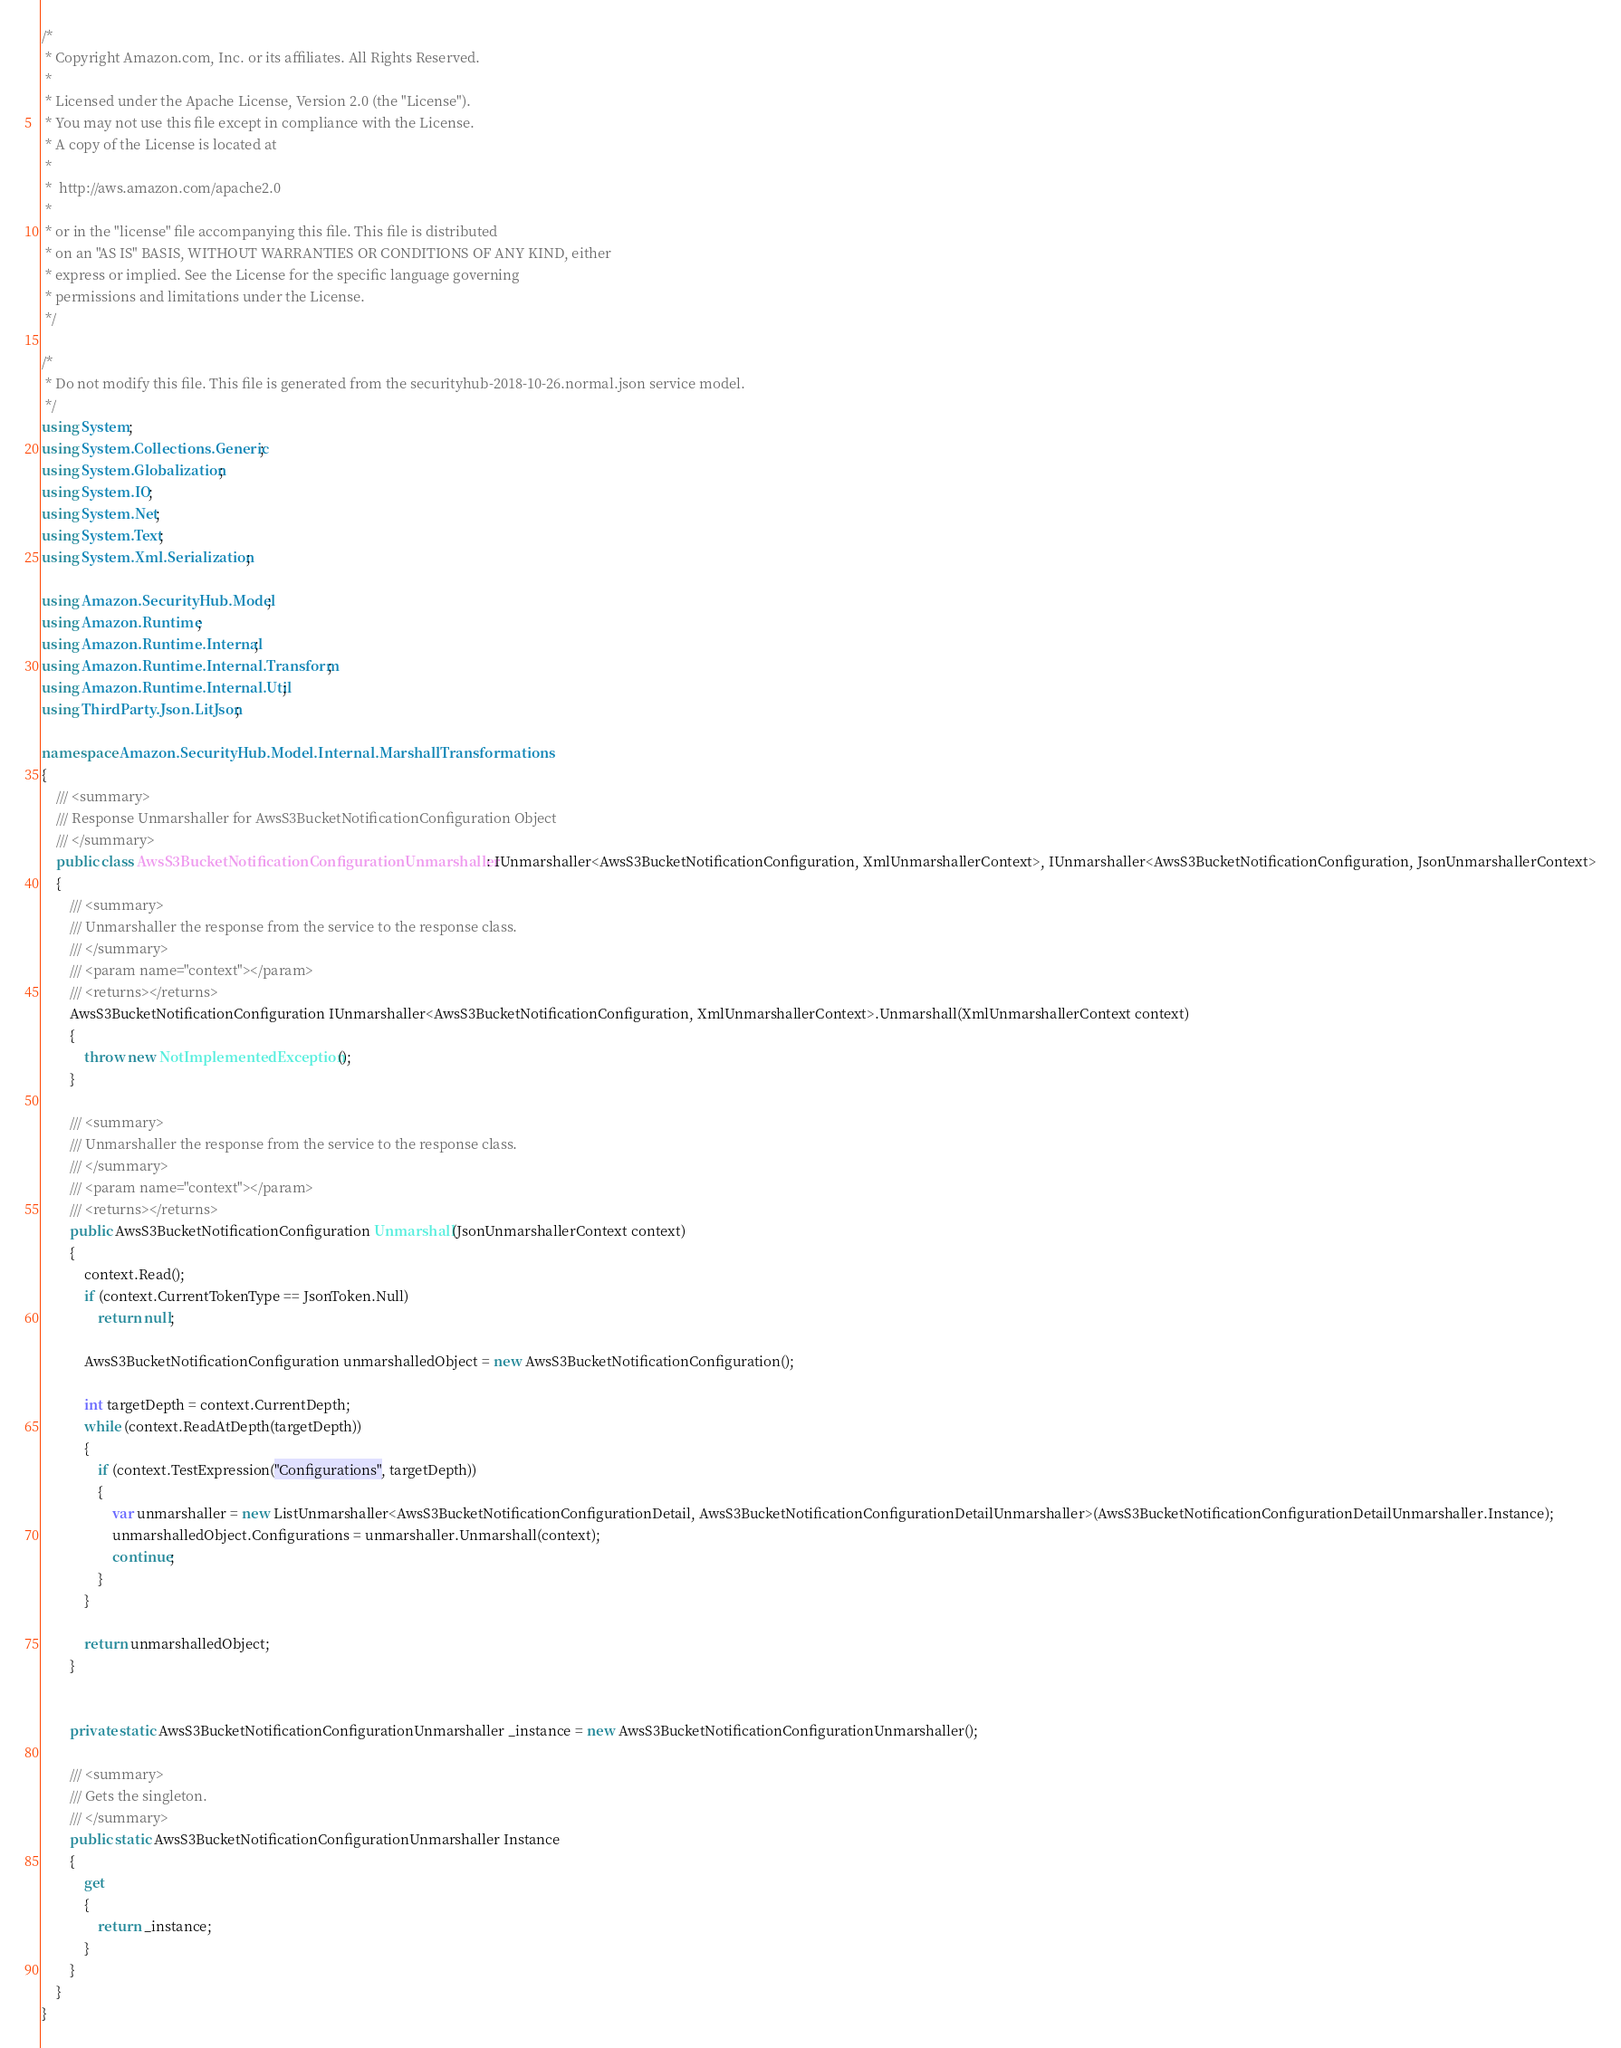Convert code to text. <code><loc_0><loc_0><loc_500><loc_500><_C#_>/*
 * Copyright Amazon.com, Inc. or its affiliates. All Rights Reserved.
 * 
 * Licensed under the Apache License, Version 2.0 (the "License").
 * You may not use this file except in compliance with the License.
 * A copy of the License is located at
 * 
 *  http://aws.amazon.com/apache2.0
 * 
 * or in the "license" file accompanying this file. This file is distributed
 * on an "AS IS" BASIS, WITHOUT WARRANTIES OR CONDITIONS OF ANY KIND, either
 * express or implied. See the License for the specific language governing
 * permissions and limitations under the License.
 */

/*
 * Do not modify this file. This file is generated from the securityhub-2018-10-26.normal.json service model.
 */
using System;
using System.Collections.Generic;
using System.Globalization;
using System.IO;
using System.Net;
using System.Text;
using System.Xml.Serialization;

using Amazon.SecurityHub.Model;
using Amazon.Runtime;
using Amazon.Runtime.Internal;
using Amazon.Runtime.Internal.Transform;
using Amazon.Runtime.Internal.Util;
using ThirdParty.Json.LitJson;

namespace Amazon.SecurityHub.Model.Internal.MarshallTransformations
{
    /// <summary>
    /// Response Unmarshaller for AwsS3BucketNotificationConfiguration Object
    /// </summary>  
    public class AwsS3BucketNotificationConfigurationUnmarshaller : IUnmarshaller<AwsS3BucketNotificationConfiguration, XmlUnmarshallerContext>, IUnmarshaller<AwsS3BucketNotificationConfiguration, JsonUnmarshallerContext>
    {
        /// <summary>
        /// Unmarshaller the response from the service to the response class.
        /// </summary>  
        /// <param name="context"></param>
        /// <returns></returns>
        AwsS3BucketNotificationConfiguration IUnmarshaller<AwsS3BucketNotificationConfiguration, XmlUnmarshallerContext>.Unmarshall(XmlUnmarshallerContext context)
        {
            throw new NotImplementedException();
        }

        /// <summary>
        /// Unmarshaller the response from the service to the response class.
        /// </summary>  
        /// <param name="context"></param>
        /// <returns></returns>
        public AwsS3BucketNotificationConfiguration Unmarshall(JsonUnmarshallerContext context)
        {
            context.Read();
            if (context.CurrentTokenType == JsonToken.Null) 
                return null;

            AwsS3BucketNotificationConfiguration unmarshalledObject = new AwsS3BucketNotificationConfiguration();
        
            int targetDepth = context.CurrentDepth;
            while (context.ReadAtDepth(targetDepth))
            {
                if (context.TestExpression("Configurations", targetDepth))
                {
                    var unmarshaller = new ListUnmarshaller<AwsS3BucketNotificationConfigurationDetail, AwsS3BucketNotificationConfigurationDetailUnmarshaller>(AwsS3BucketNotificationConfigurationDetailUnmarshaller.Instance);
                    unmarshalledObject.Configurations = unmarshaller.Unmarshall(context);
                    continue;
                }
            }
          
            return unmarshalledObject;
        }


        private static AwsS3BucketNotificationConfigurationUnmarshaller _instance = new AwsS3BucketNotificationConfigurationUnmarshaller();        

        /// <summary>
        /// Gets the singleton.
        /// </summary>  
        public static AwsS3BucketNotificationConfigurationUnmarshaller Instance
        {
            get
            {
                return _instance;
            }
        }
    }
}</code> 